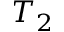Convert formula to latex. <formula><loc_0><loc_0><loc_500><loc_500>T _ { 2 }</formula> 